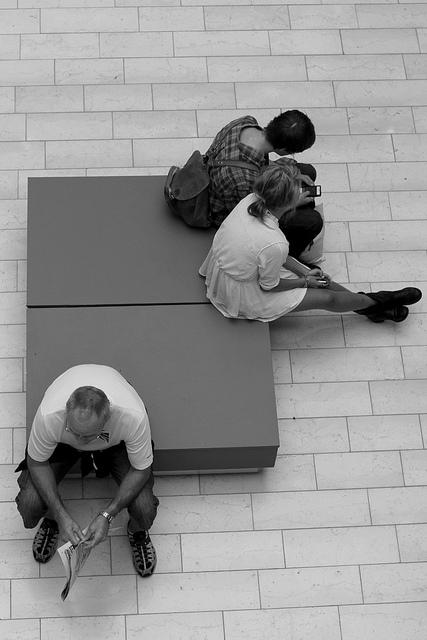Was this picture taken at ground level?
Be succinct. No. How do you feel that this picture being in black in white makes it more interesting?
Write a very short answer. Yes. How many men are in this picture?
Give a very brief answer. 1. 